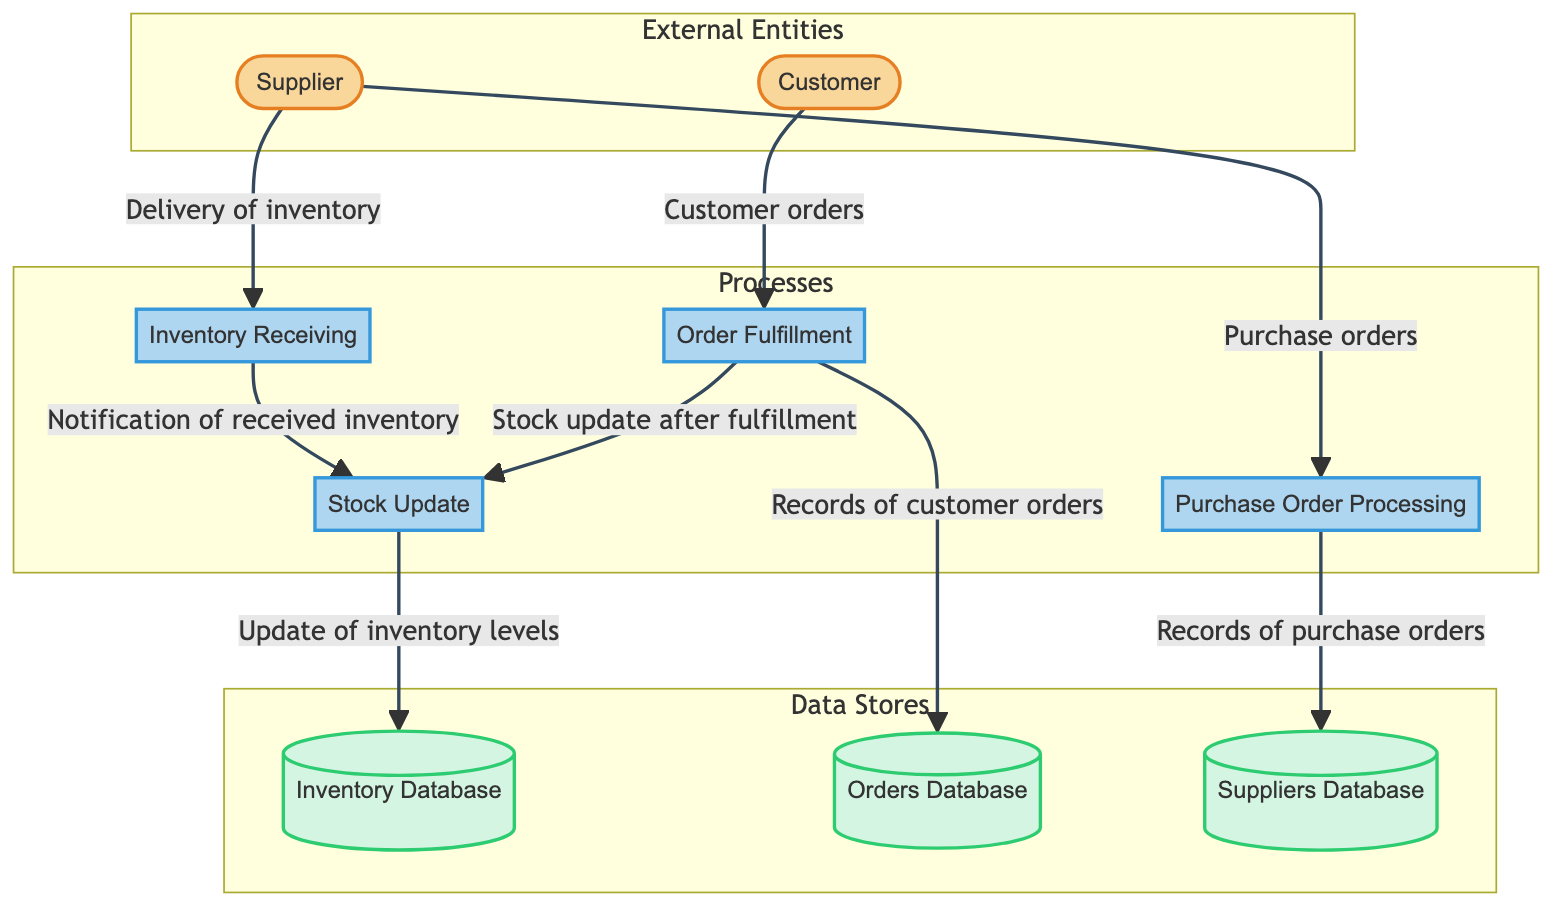What are the external entities in this diagram? The external entities are Supplier and Customer, as indicated at the top of the diagram.
Answer: Supplier, Customer How many processes are represented in the diagram? There are four processes: Purchase Order Processing, Inventory Receiving, Order Fulfillment, and Stock Update. They can be counted from the processes section of the diagram.
Answer: Four What does the Supplier send to Purchase Order Processing? The Supplier sends purchase orders to the Purchase Order Processing as shown in the data flow from Supplier to this process in the diagram.
Answer: Purchase orders Which process updates the Inventory Database? The Stock Update process updates the Inventory Database, as evidenced by the flow from Stock Update to Inventory Database in the diagram.
Answer: Stock Update How many data stores are present in the diagram? The diagram shows three data stores: Inventory Database, Orders Database, and Suppliers Database. A visual count of the data store nodes confirms this.
Answer: Three What is the relationship between Order Fulfillment and Orders Database? Order Fulfillment sends records of customer orders to the Orders Database, which is depicted in the data flow from Order Fulfillment to Orders Database in the diagram.
Answer: Sends records Which entity triggers the Inventory Receiving process? The Supplier triggers the Inventory Receiving process by sending delivery of inventory items, as illustrated by the data flow from Supplier to Inventory Receiving in the diagram.
Answer: Supplier What action follows the Inventory Receiving process? The action that follows Inventory Receiving is Software Update, as indicated by the flow from Inventory Receiving to Stock Update in the diagram.
Answer: Stock Update Which process handles customer orders? The process that handles customer orders is Order Fulfillment, as shown in the flow from Customer to Order Fulfillment in the diagram.
Answer: Order Fulfillment What information is stored in the Suppliers Database? The Suppliers Database holds supplier information and purchase order history, as described in the data store section of the diagram.
Answer: Supplier information and purchase order history 